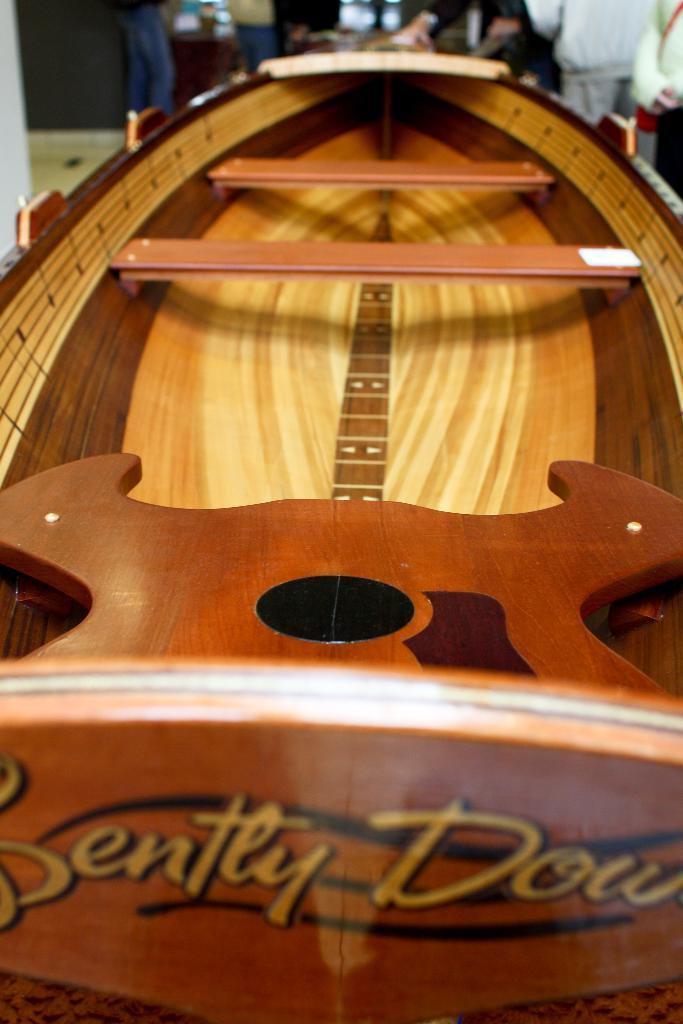What type of toy is in the image? There is a toy wooden boat in the image. What material is the boat made of? The boat is made of wood. What feature does the boat have inside? The boat has wooden benches. Are the wooden benches attached to the boat? Yes, the wooden benches are fixed in the boat. What can be seen in the background of the image? There are people standing in the background of the image. What type of drain is visible in the image? There is no drain present in the image; it features a toy wooden boat with wooden benches. What grade of wood was used to make the boat? The facts provided do not specify the grade of wood used to make the boat. 